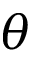<formula> <loc_0><loc_0><loc_500><loc_500>\theta</formula> 